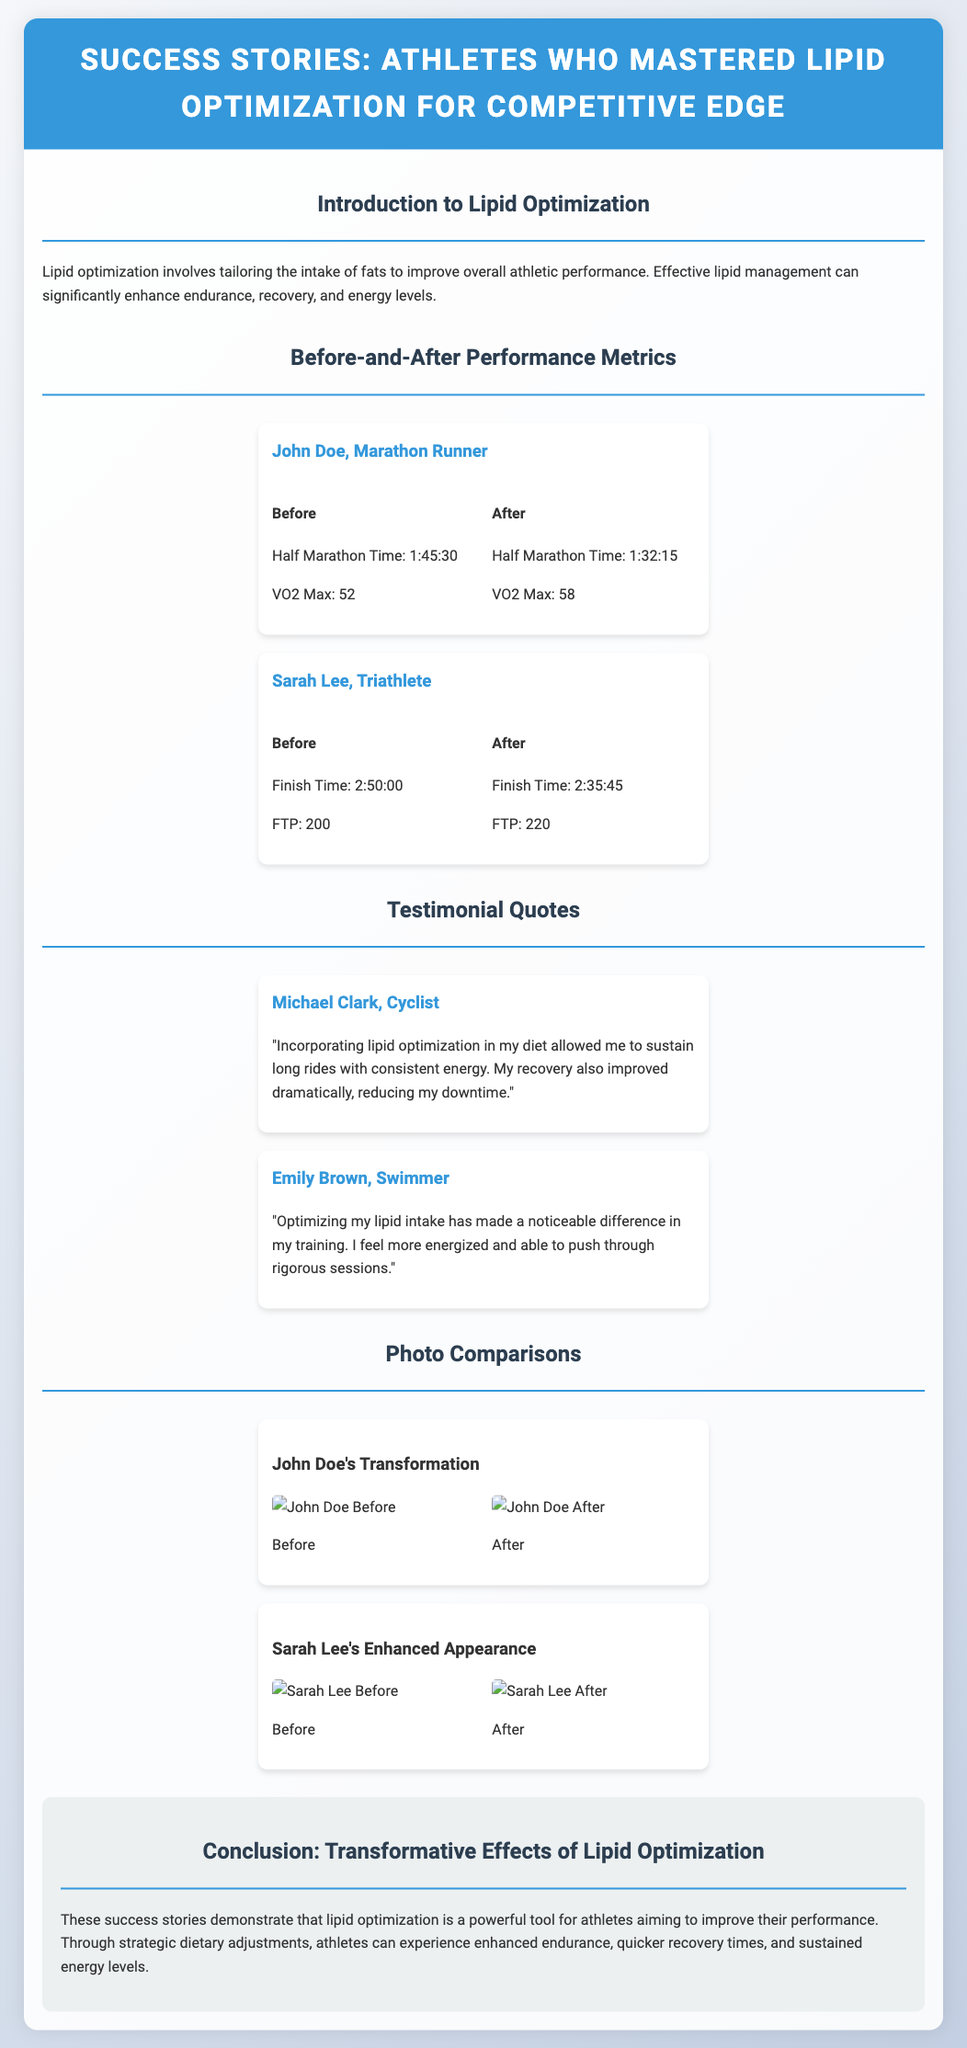What is the title of the presentation? The title is prominently displayed at the top of the document.
Answer: Success Stories: Athletes Who Mastered Lipid Optimization for Competitive Edge Who is the marathon runner mentioned in the performance metrics? The identity of the marathon runner is found within the performance metrics section.
Answer: John Doe What was John Doe's Half Marathon time before optimization? The document provides specific performance metrics for John Doe before and after lipid optimization.
Answer: 1:45:30 What improvement did Sarah Lee achieve in her finish time? This question combines her before and after times to find the improvement made.
Answer: 14:15 Who provided a testimonial about long rides? The testimonials include specific athlete names who shared their experiences.
Answer: Michael Clark What was Sarah Lee's FTP after optimization? The document indicates the FTP values for Sarah Lee before and after optimization.
Answer: 220 What is mentioned as a key benefit of lipid optimization in the conclusion? The conclusion summarizes the effects and benefits described in the document.
Answer: Enhanced endurance How many athletes are featured in the photo comparisons? The document lists the athletes who underwent transformations and includes their photo comparisons.
Answer: 2 